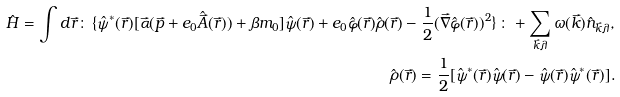<formula> <loc_0><loc_0><loc_500><loc_500>\hat { H } = \int d \vec { r } \colon \, \{ \hat { \psi } ^ { * } ( \vec { r } ) [ \vec { \alpha } ( \vec { p } + e _ { 0 } \hat { \vec { A } } ( \vec { r } ) ) + \beta m _ { 0 } ] \hat { \psi } ( \vec { r } ) + e _ { 0 } \hat { \varphi } ( \vec { r } ) \hat { \rho } ( \vec { r } ) - \frac { 1 } { 2 } ( \vec { \nabla } \hat { \varphi } ( \vec { r } ) ) ^ { 2 } \} \, \colon + \sum _ { \vec { k } \lambda } \omega ( \vec { k } ) \hat { n } _ { \vec { k } \lambda } , \\ \hat { \rho } ( \vec { r } ) = \frac { 1 } { 2 } [ \hat { \psi } ^ { * } ( \vec { r } ) \hat { \psi } ( \vec { r } ) - \hat { \psi } ( \vec { r } ) \hat { \psi } ^ { * } ( \vec { r } ) ] .</formula> 